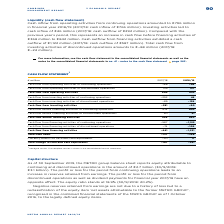According to Metro Ag's financial document, What version is the cash flow statement in the table in? According to the financial document, Abridged version. The relevant text states: "1 Abridged version. The complete version is shown in the consolidated financial statements...." Also, Where can the complete version of the cash flow statement be found? The complete version is shown in the consolidated financial statements.. The document states: "1 Abridged version. The complete version is shown in the consolidated financial statements...." Also, What is the Cash flow from operating activities in FY2019? According to the financial document, 953 (in millions). The relevant text states: "Cash flow from operating activities 905 953..." Additionally, In which year was the Cash flow from operating activities larger? According to the financial document, 2018/19. The relevant text states: "€ million 2017/18 2018/19..." Also, can you calculate: What was the change in cash flow from operating activities in FY2019 from FY2018? Based on the calculation: 953-905, the result is 48 (in millions). This is based on the information: "Cash flow from operating activities 905 953 Cash flow from operating activities 905 953..." The key data points involved are: 905, 953. Also, can you calculate: What was the percentage change in cash flow from operating activities in FY2019 from FY2018? To answer this question, I need to perform calculations using the financial data. The calculation is: (953-905)/905, which equals 5.3 (percentage). This is based on the information: "Cash flow from operating activities 905 953 Cash flow from operating activities 905 953..." The key data points involved are: 905, 953. 